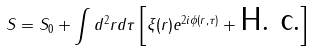Convert formula to latex. <formula><loc_0><loc_0><loc_500><loc_500>S = S _ { 0 } + \int d ^ { 2 } r d \tau \left [ \xi ( r ) e ^ { 2 i \phi ( r , \tau ) } + \text {H. c.} \right ]</formula> 